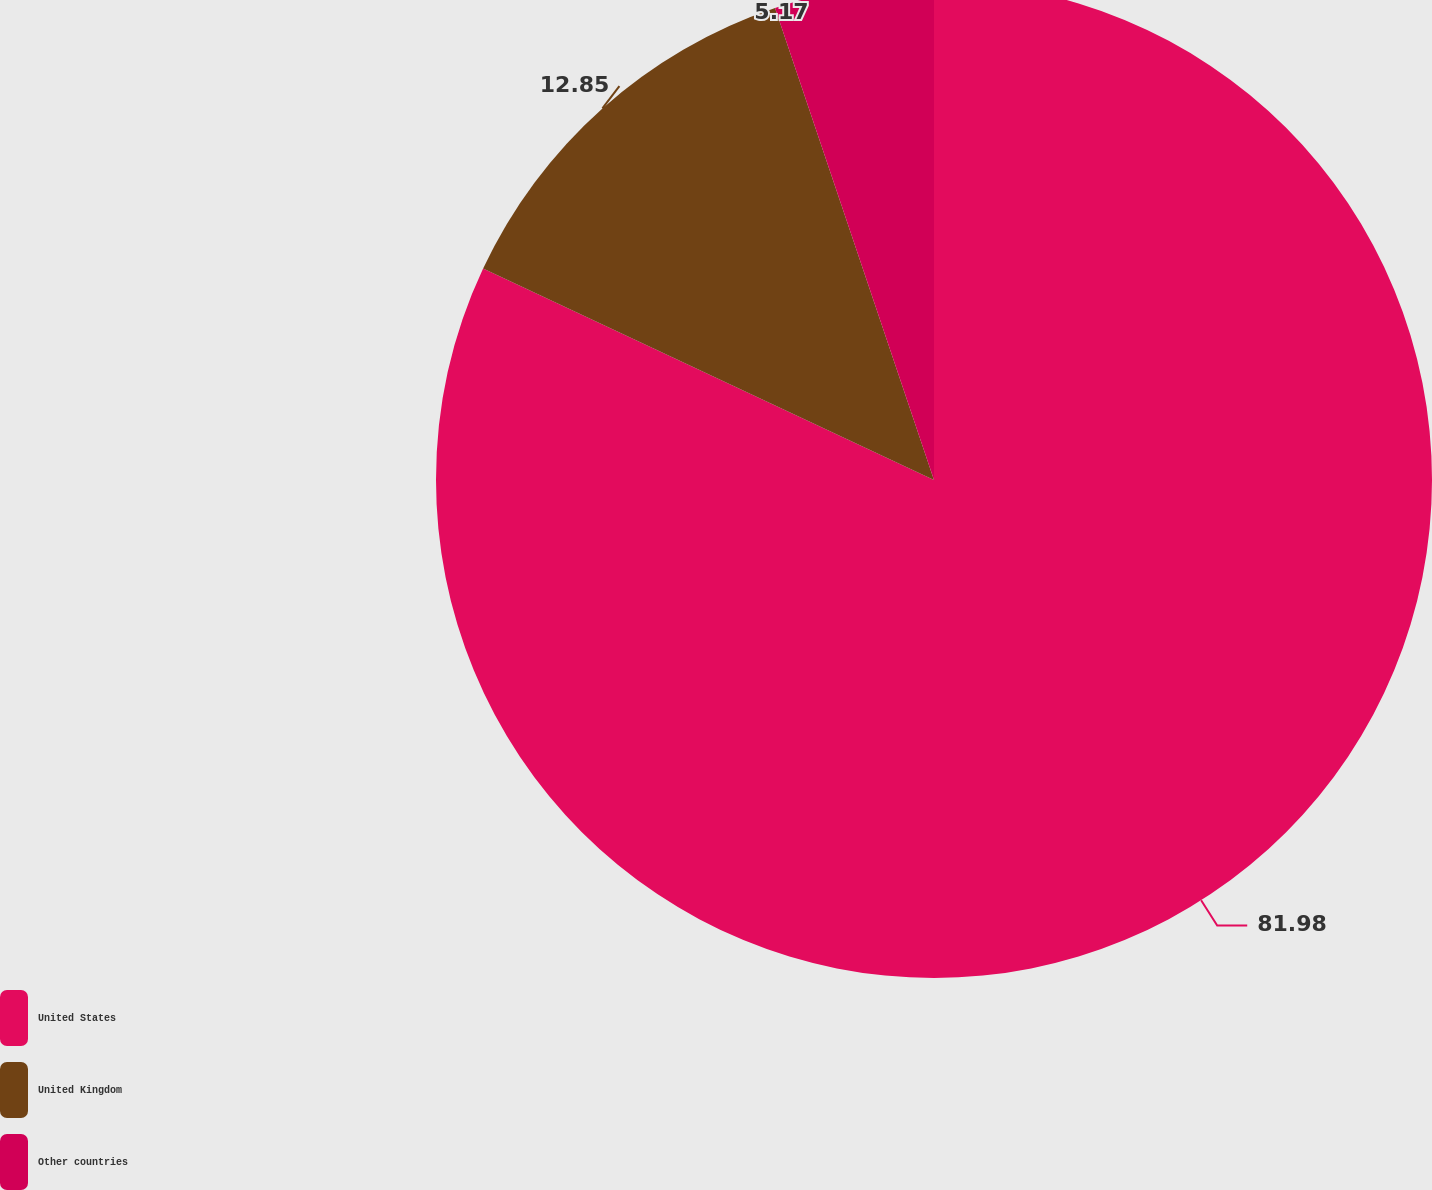Convert chart. <chart><loc_0><loc_0><loc_500><loc_500><pie_chart><fcel>United States<fcel>United Kingdom<fcel>Other countries<nl><fcel>81.97%<fcel>12.85%<fcel>5.17%<nl></chart> 